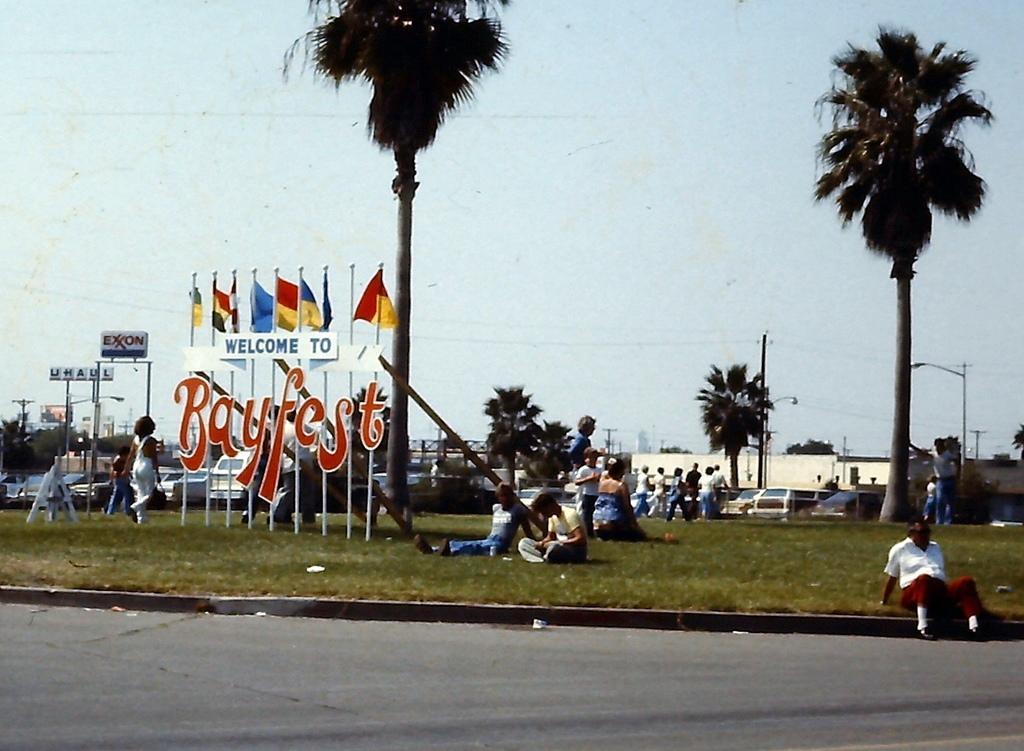How would you summarize this image in a sentence or two? In this image, we can see few people. Few are sitting, standing and walking. Here we can see grass, few flags with poles, hoardings, trees, houses, vehicles. At the bottom, there is a road. Background there is a sky. 